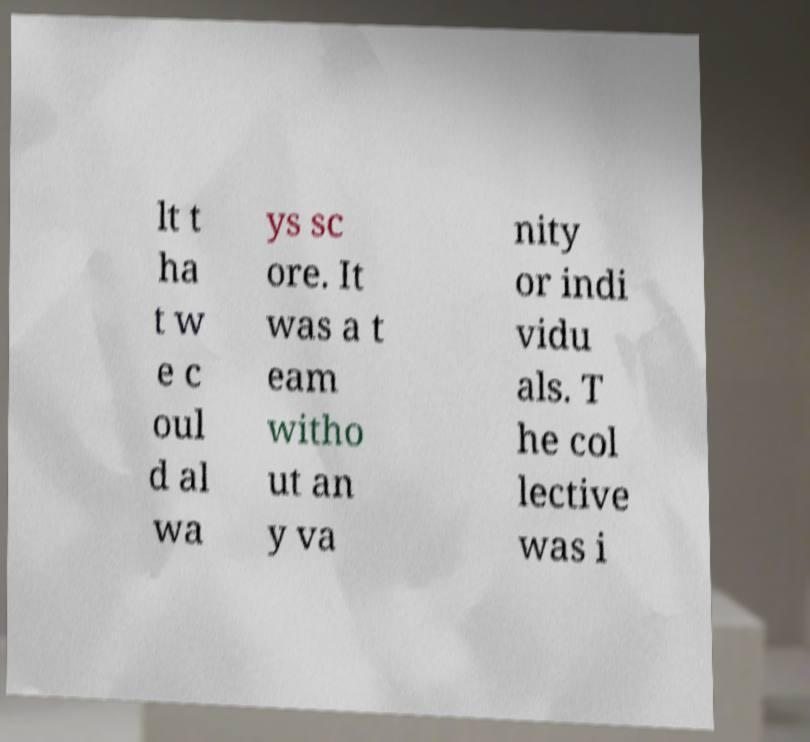Could you extract and type out the text from this image? lt t ha t w e c oul d al wa ys sc ore. It was a t eam witho ut an y va nity or indi vidu als. T he col lective was i 